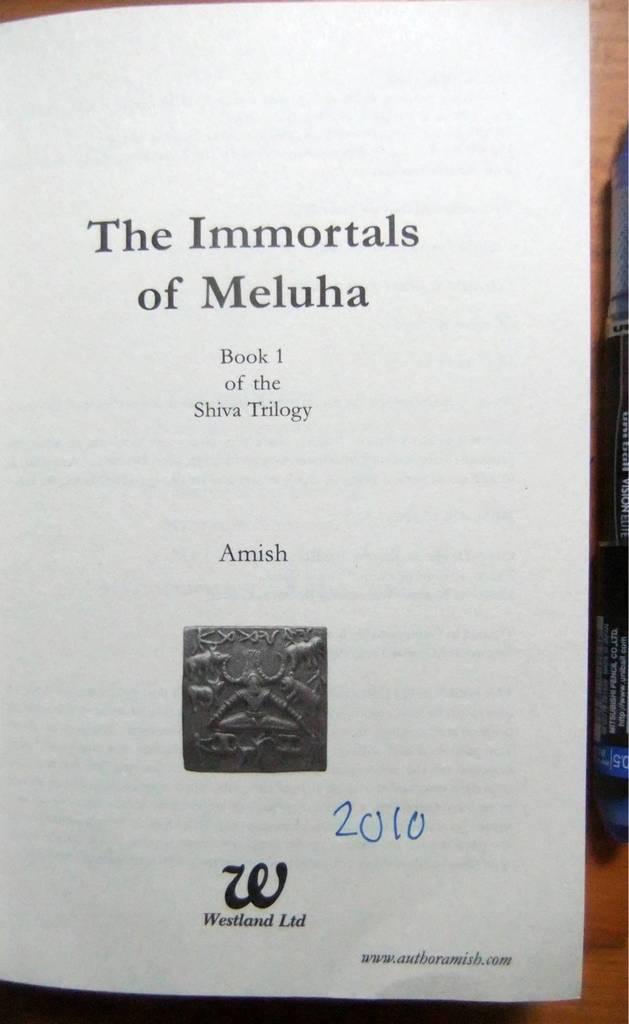What year is mentioned below?
Provide a succinct answer. 2010. 